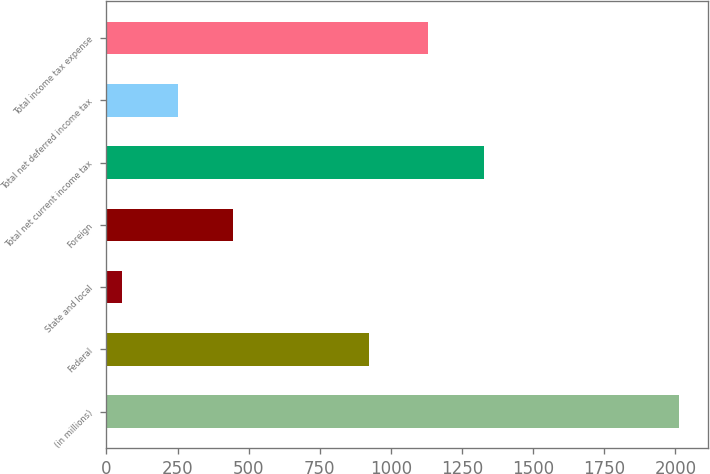<chart> <loc_0><loc_0><loc_500><loc_500><bar_chart><fcel>(in millions)<fcel>Federal<fcel>State and local<fcel>Foreign<fcel>Total net current income tax<fcel>Total net deferred income tax<fcel>Total income tax expense<nl><fcel>2014<fcel>923<fcel>54<fcel>446<fcel>1327<fcel>250<fcel>1131<nl></chart> 